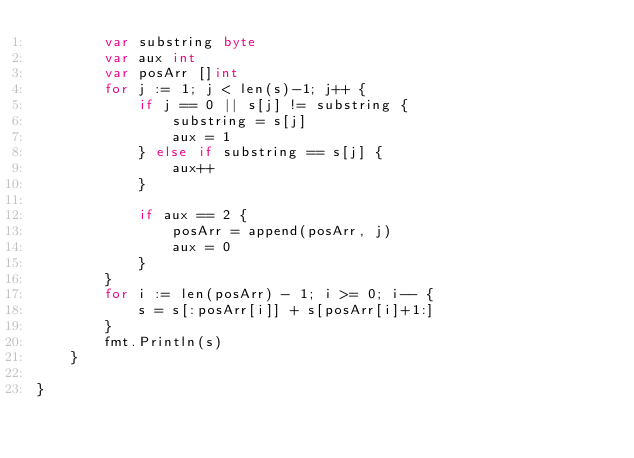Convert code to text. <code><loc_0><loc_0><loc_500><loc_500><_Go_>		var substring byte
		var aux int
		var posArr []int
		for j := 1; j < len(s)-1; j++ {
			if j == 0 || s[j] != substring {
				substring = s[j]
				aux = 1
			} else if substring == s[j] {
				aux++
			}

			if aux == 2 {
				posArr = append(posArr, j)
				aux = 0
			}
		}
		for i := len(posArr) - 1; i >= 0; i-- {
			s = s[:posArr[i]] + s[posArr[i]+1:]
		}
		fmt.Println(s)
	}

}
</code> 